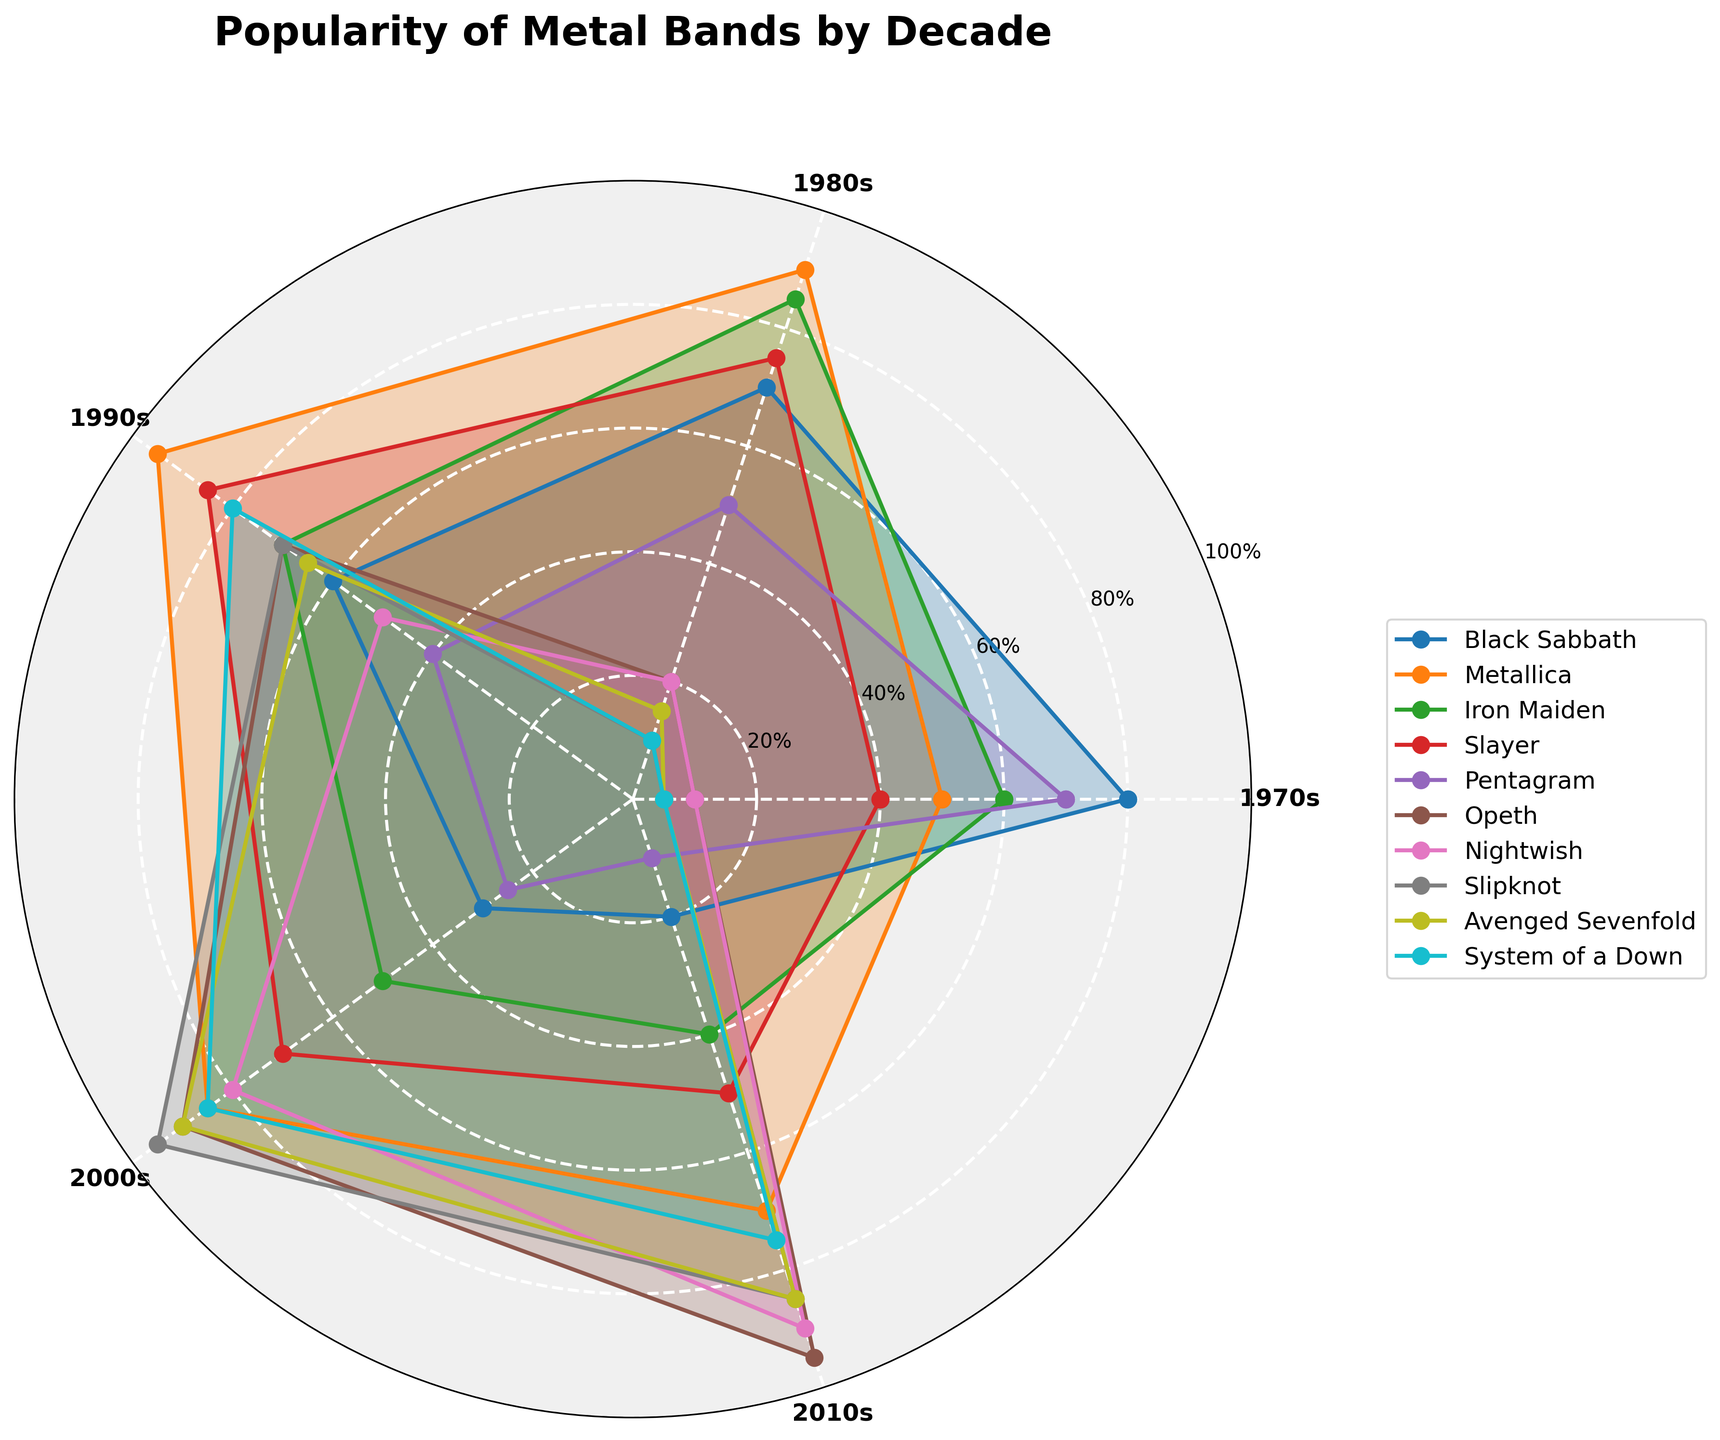Which decade shows the highest popularity for Metallica? The line representing Metallica can be traced around the angular positions representing different decades. The highest value for Metallica will correspond to the 1990s.
Answer: 1990s What is the average popularity of Iron Maiden across all decades? The popularity values of Iron Maiden across the decades are: 1970s: 60, 1980s: 85, 1990s: 70, 2000s: 50, 2010s: 40. The average is calculated as (60 + 85 + 70 + 50 + 40) / 5 = 61.
Answer: 61 Which two bands have the closest popularity rates in the 2000s? Look at the values at the radial position for the 2000s. Opeth has a value of 90, and Avenged Sevenfold has a value of 90. Both have equal popularity rates in the 2000s.
Answer: Opeth and Avenged Sevenfold During which decade did Black Sabbath experience a dramatic drop in popularity? Black Sabbath starts with 80 in the 1970s and drops down to 30 in the 2000s. The most significant single drop can be seen from the 1980s to the 1990s.
Answer: 1990s Which band saw a consistent increase in popularity from the 1970s to the 2010s? The band whose values are increasing steadily over the decades is Opeth, with values moving from 10 in the 1970s to 95 in the 2010s.
Answer: Opeth In the 2010s, which band's popularity is significantly higher than in the 1970s? Compare the popularity values between the 1970s and 2010s. Nightwish shows a jump from 10 in the 1970s to 90 in the 2010s.
Answer: Nightwish What is the combined popularity of Slipknot in the 2000s and Nightwish in the 2010s? The popularity of Slipknot in the 2000s is 95, and Nightwish in the 2010s is 90. Their combined popularity is 95 + 90 = 185.
Answer: 185 Which decade saw the highest number of bands with a popularity value of 85 or more? Check the values for each decade and count the number of bands with values of 85 or more. In the 2000s, Metallica (85), Opeth (90), Nightwish (80), Slipknot (95), and Avenged Sevenfold (90) qualify, summing to 5 bands.
Answer: 2000s 